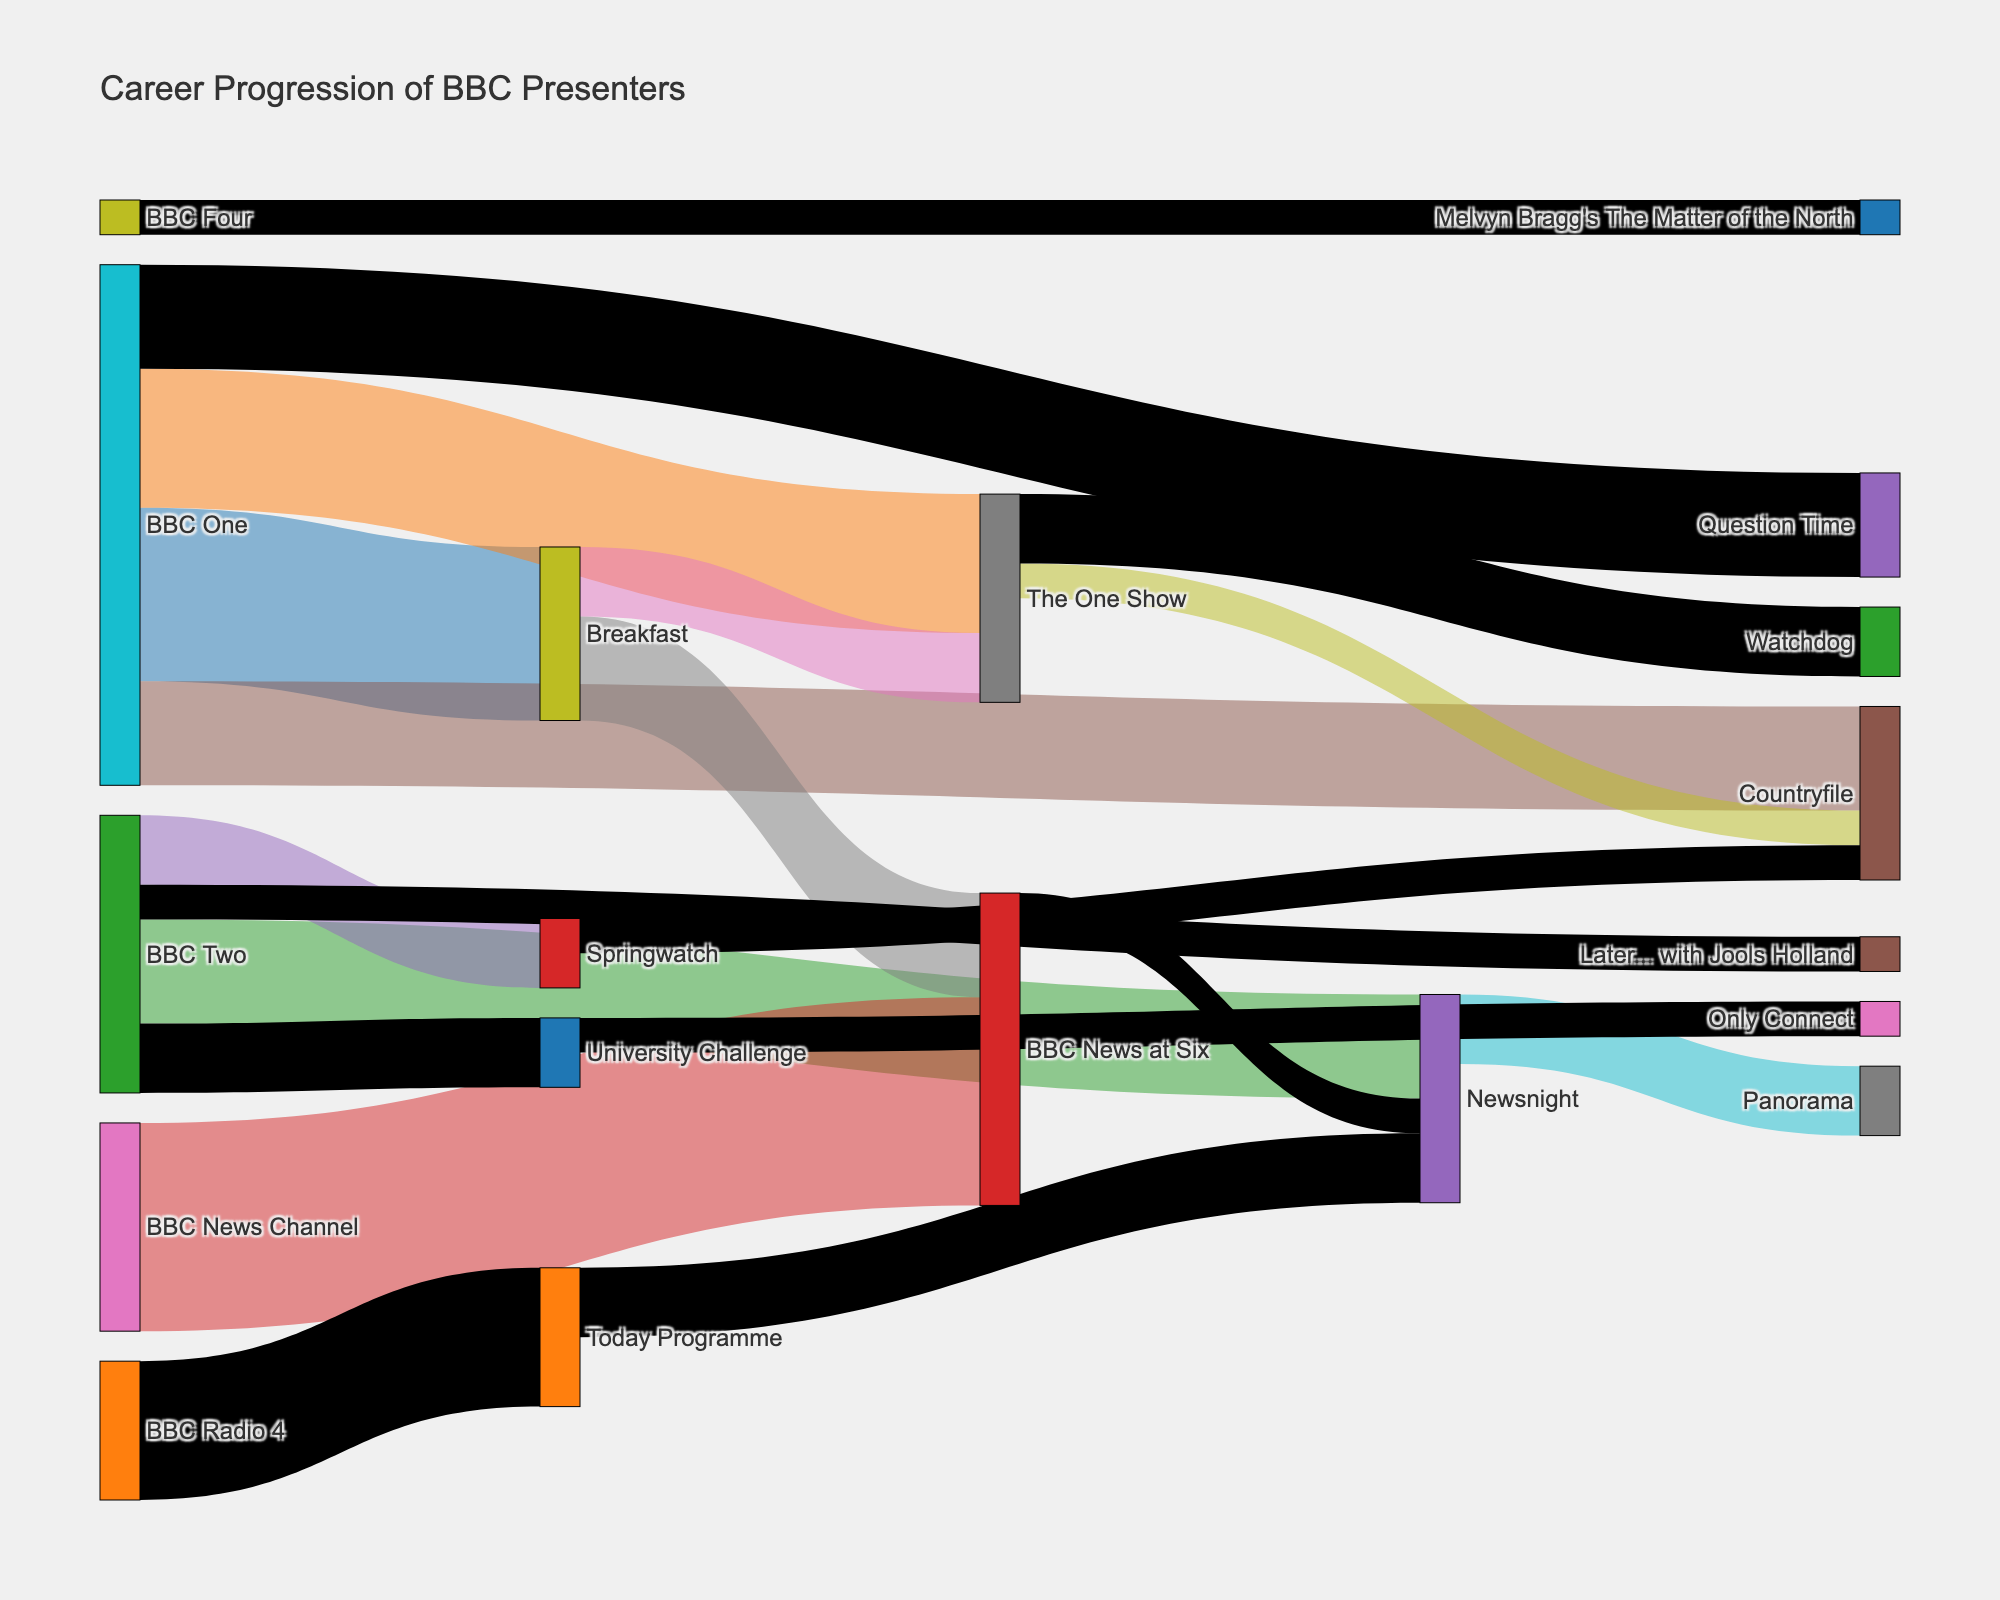What's the title of the figure? The title of the figure is typically located at the top and is prominently displayed in a larger font size. The figure title helps summarize the content or purpose of the diagram.
Answer: Career Progression of BBC Presenters How many presenters from BBC One moved to Breakfast? Look for the link connecting "BBC One" to "Breakfast" and check the value labeled on that link.
Answer: 5 Which channel has the highest number of presenters moving to another show? Identify the source nodes and check the sum of the values of outgoing flows for each source node. "BBC News Channel" has flows with the highest cumulative value.
Answer: BBC News Channel What is the sum of presenters who moved from Breakfast to other shows? Sum the values of the links originating from "Breakfast". Add the values labeled on these outgoing links (2 for "The One Show" and 3 for "BBC News at Six").
Answer: 5 How many presenters moved from Newsnight to Panorama? Look for the link connecting "Newsnight" to "Panorama" and check the value labeled on that link.
Answer: 2 Which two shows did presenters move to after appearing on BBC Two's Springwatch? Identify the target nodes connected to "Springwatch" and check the labels for those links.
Answer: BBC Two's Springwatch How many presenters were involved in transitions to/from BBC News at Six? Count all presenters moving to "BBC News at Six" and from "BBC News at Six". Add 6 (from "BBC News Channel") and 1 (to "Newsnight").
Answer: 7 Which show on BBC Four is represented in the diagram? Find the node that corresponds to a show on BBC Four. BBC Four's node connected to a show.
Answer: Melvyn Bragg's The Matter of the North Which show saw the least transition of presenters from University Challenge? Look for the links originating from "University Challenge" and identify the one with the lowest value.
Answer: Only Connect What is the total number of transitions involving BBC Radio 4? Sum the values for all flows related to "BBC Radio 4". The only link is moving 4 presenters to the "Today Programme".
Answer: 4 